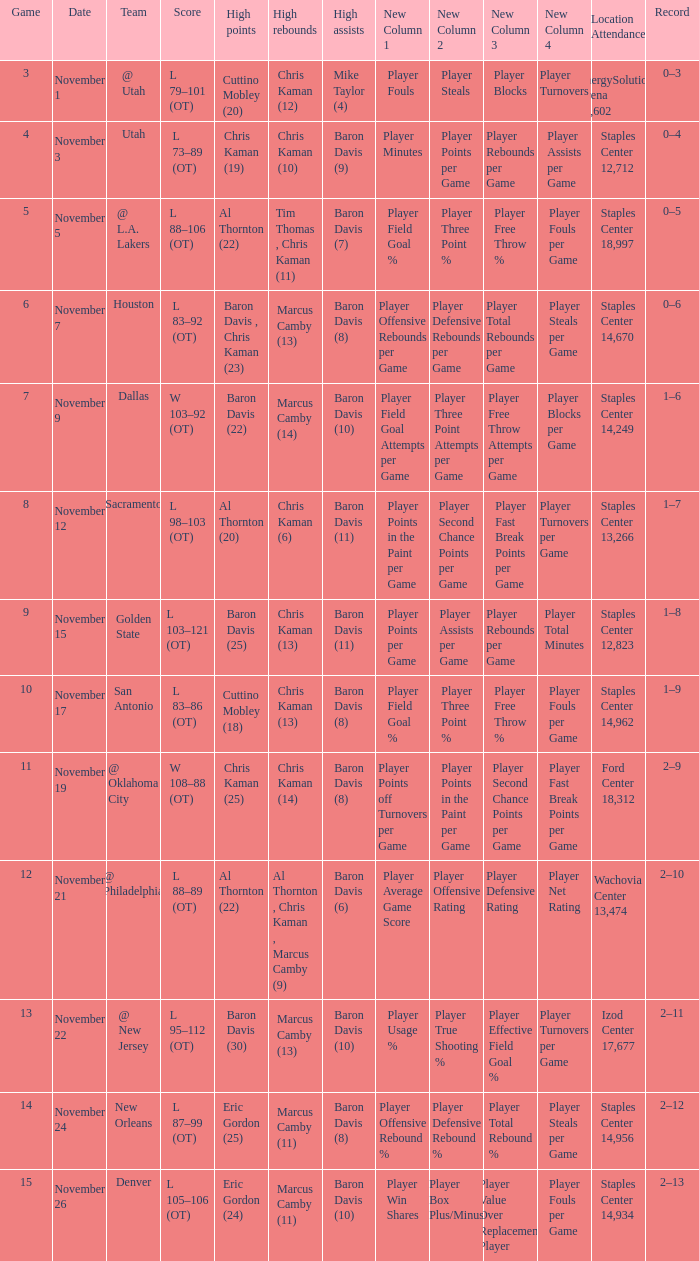Name the total number of score for staples center 13,266 1.0. 